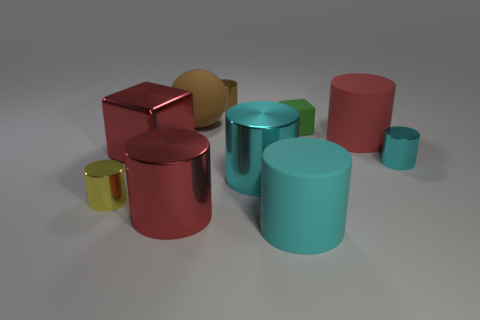How many cyan cylinders must be subtracted to get 1 cyan cylinders? 2 Subtract all gray balls. How many cyan cylinders are left? 3 Subtract all yellow cylinders. How many cylinders are left? 6 Subtract all red rubber cylinders. How many cylinders are left? 6 Subtract all brown blocks. Subtract all yellow spheres. How many blocks are left? 2 Subtract all cylinders. How many objects are left? 3 Subtract all big matte cylinders. Subtract all small metallic cylinders. How many objects are left? 5 Add 4 green rubber blocks. How many green rubber blocks are left? 5 Add 4 red metallic things. How many red metallic things exist? 6 Subtract 1 yellow cylinders. How many objects are left? 9 